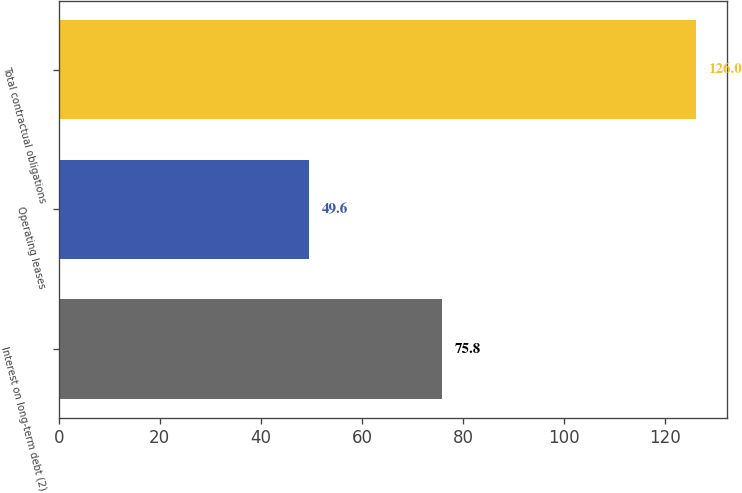Convert chart to OTSL. <chart><loc_0><loc_0><loc_500><loc_500><bar_chart><fcel>Interest on long-term debt (2)<fcel>Operating leases<fcel>Total contractual obligations<nl><fcel>75.8<fcel>49.6<fcel>126<nl></chart> 